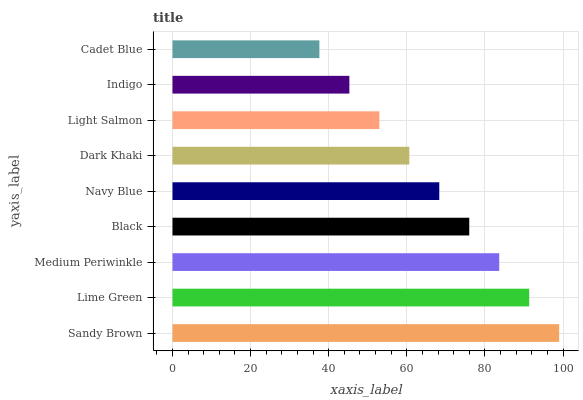Is Cadet Blue the minimum?
Answer yes or no. Yes. Is Sandy Brown the maximum?
Answer yes or no. Yes. Is Lime Green the minimum?
Answer yes or no. No. Is Lime Green the maximum?
Answer yes or no. No. Is Sandy Brown greater than Lime Green?
Answer yes or no. Yes. Is Lime Green less than Sandy Brown?
Answer yes or no. Yes. Is Lime Green greater than Sandy Brown?
Answer yes or no. No. Is Sandy Brown less than Lime Green?
Answer yes or no. No. Is Navy Blue the high median?
Answer yes or no. Yes. Is Navy Blue the low median?
Answer yes or no. Yes. Is Dark Khaki the high median?
Answer yes or no. No. Is Cadet Blue the low median?
Answer yes or no. No. 